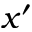Convert formula to latex. <formula><loc_0><loc_0><loc_500><loc_500>x ^ { \prime }</formula> 